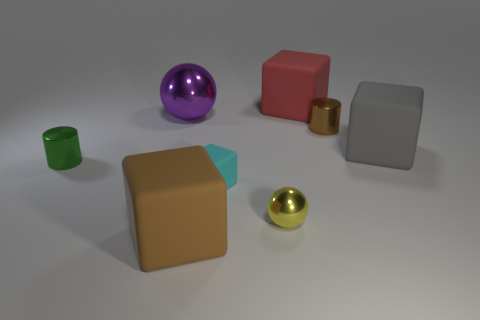There is a big thing that is in front of the gray thing; is its shape the same as the small green object left of the large red cube?
Your answer should be very brief. No. What number of things are yellow metal cylinders or small yellow metallic balls that are in front of the large red thing?
Offer a very short reply. 1. How many other things are the same shape as the large gray thing?
Offer a terse response. 3. Does the large cube to the right of the red thing have the same material as the large brown object?
Your response must be concise. Yes. What number of objects are purple metal spheres or small gray metal objects?
Ensure brevity in your answer.  1. What size is the purple object that is the same shape as the yellow shiny thing?
Ensure brevity in your answer.  Large. What is the size of the cyan cube?
Offer a terse response. Small. Is the number of small brown shiny cylinders that are to the left of the purple metallic object greater than the number of small cyan blocks?
Provide a succinct answer. No. Is there any other thing that is the same material as the cyan thing?
Your answer should be very brief. Yes. Does the metal sphere that is behind the tiny yellow sphere have the same color as the rubber cube that is on the right side of the large red matte thing?
Offer a terse response. No. 